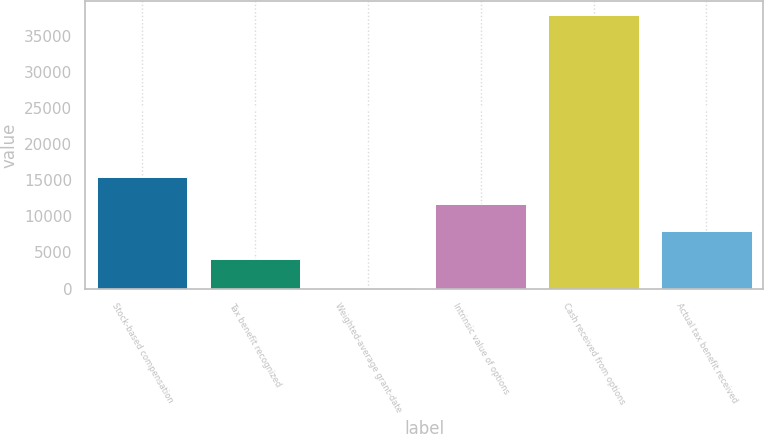<chart> <loc_0><loc_0><loc_500><loc_500><bar_chart><fcel>Stock-based compensation<fcel>Tax benefit recognized<fcel>Weighted-average grant-date<fcel>Intrinsic value of options<fcel>Cash received from options<fcel>Actual tax benefit received<nl><fcel>15501.2<fcel>4147<fcel>15.53<fcel>11716.5<fcel>37863<fcel>7931.75<nl></chart> 